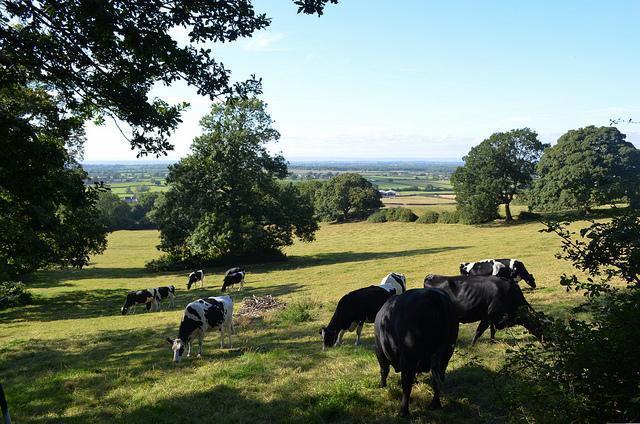How many cows are there?
Give a very brief answer. 4. 